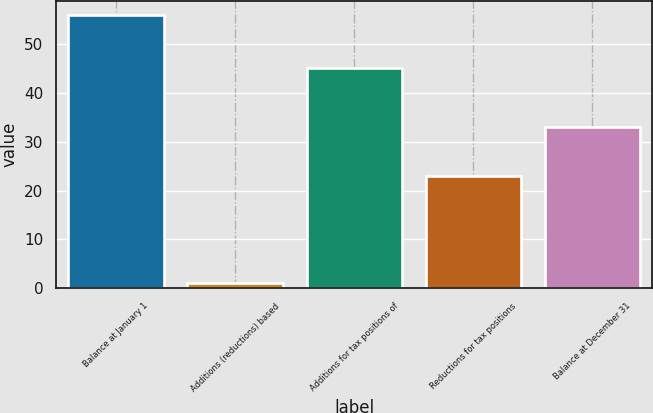Convert chart to OTSL. <chart><loc_0><loc_0><loc_500><loc_500><bar_chart><fcel>Balance at January 1<fcel>Additions (reductions) based<fcel>Additions for tax positions of<fcel>Reductions for tax positions<fcel>Balance at December 31<nl><fcel>56<fcel>1<fcel>45<fcel>23<fcel>33<nl></chart> 